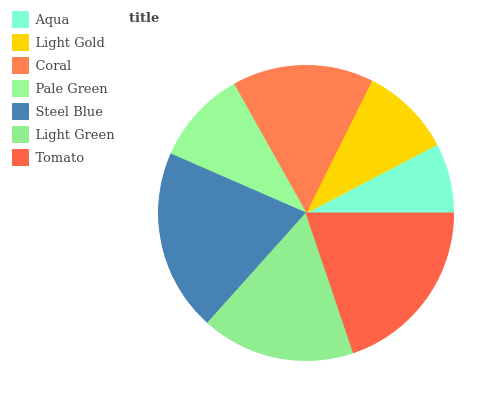Is Aqua the minimum?
Answer yes or no. Yes. Is Steel Blue the maximum?
Answer yes or no. Yes. Is Light Gold the minimum?
Answer yes or no. No. Is Light Gold the maximum?
Answer yes or no. No. Is Light Gold greater than Aqua?
Answer yes or no. Yes. Is Aqua less than Light Gold?
Answer yes or no. Yes. Is Aqua greater than Light Gold?
Answer yes or no. No. Is Light Gold less than Aqua?
Answer yes or no. No. Is Coral the high median?
Answer yes or no. Yes. Is Coral the low median?
Answer yes or no. Yes. Is Tomato the high median?
Answer yes or no. No. Is Tomato the low median?
Answer yes or no. No. 